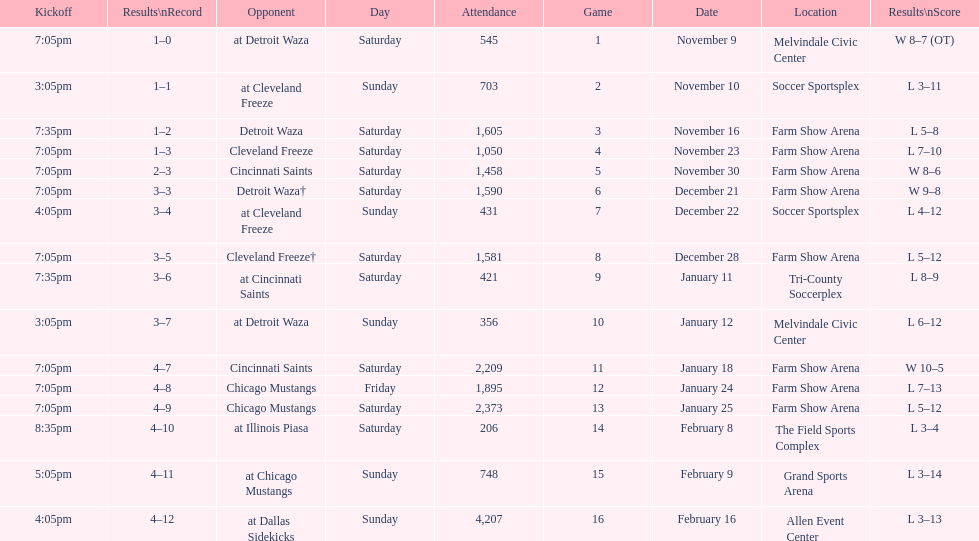Which opponent is listed first in the table? Detroit Waza. 